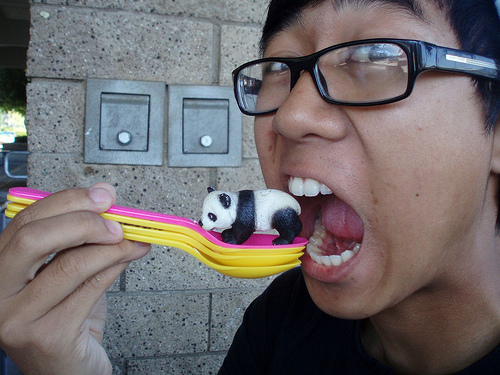<image>
Can you confirm if the finger is on the finger? Yes. Looking at the image, I can see the finger is positioned on top of the finger, with the finger providing support. Where is the panda in relation to the tooth? Is it under the tooth? Yes. The panda is positioned underneath the tooth, with the tooth above it in the vertical space. Where is the panda in relation to the yellow spoon? Is it in the yellow spoon? No. The panda is not contained within the yellow spoon. These objects have a different spatial relationship. 